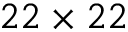<formula> <loc_0><loc_0><loc_500><loc_500>2 2 \times 2 2</formula> 